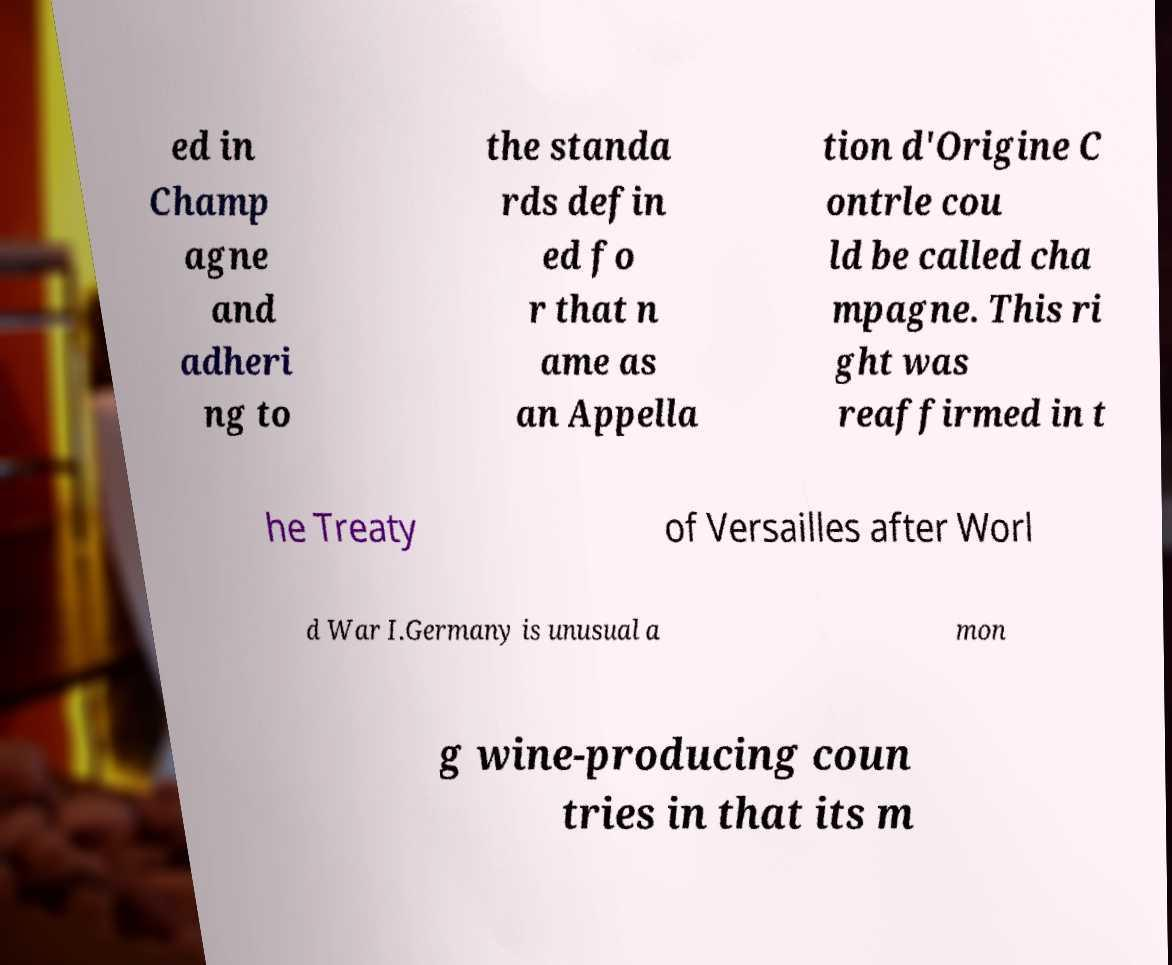Please identify and transcribe the text found in this image. ed in Champ agne and adheri ng to the standa rds defin ed fo r that n ame as an Appella tion d'Origine C ontrle cou ld be called cha mpagne. This ri ght was reaffirmed in t he Treaty of Versailles after Worl d War I.Germany is unusual a mon g wine-producing coun tries in that its m 